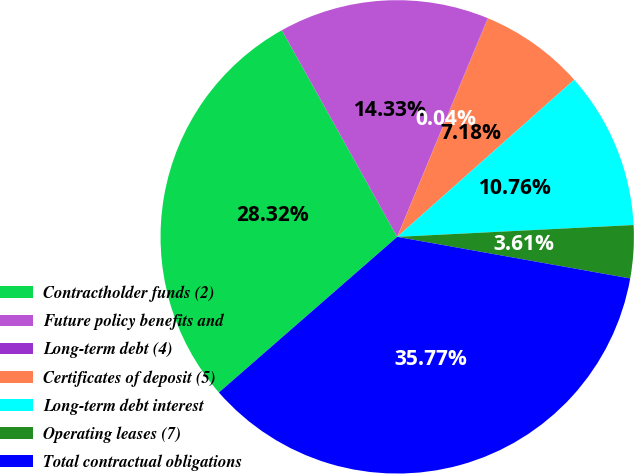Convert chart. <chart><loc_0><loc_0><loc_500><loc_500><pie_chart><fcel>Contractholder funds (2)<fcel>Future policy benefits and<fcel>Long-term debt (4)<fcel>Certificates of deposit (5)<fcel>Long-term debt interest<fcel>Operating leases (7)<fcel>Total contractual obligations<nl><fcel>28.32%<fcel>14.33%<fcel>0.04%<fcel>7.18%<fcel>10.76%<fcel>3.61%<fcel>35.77%<nl></chart> 